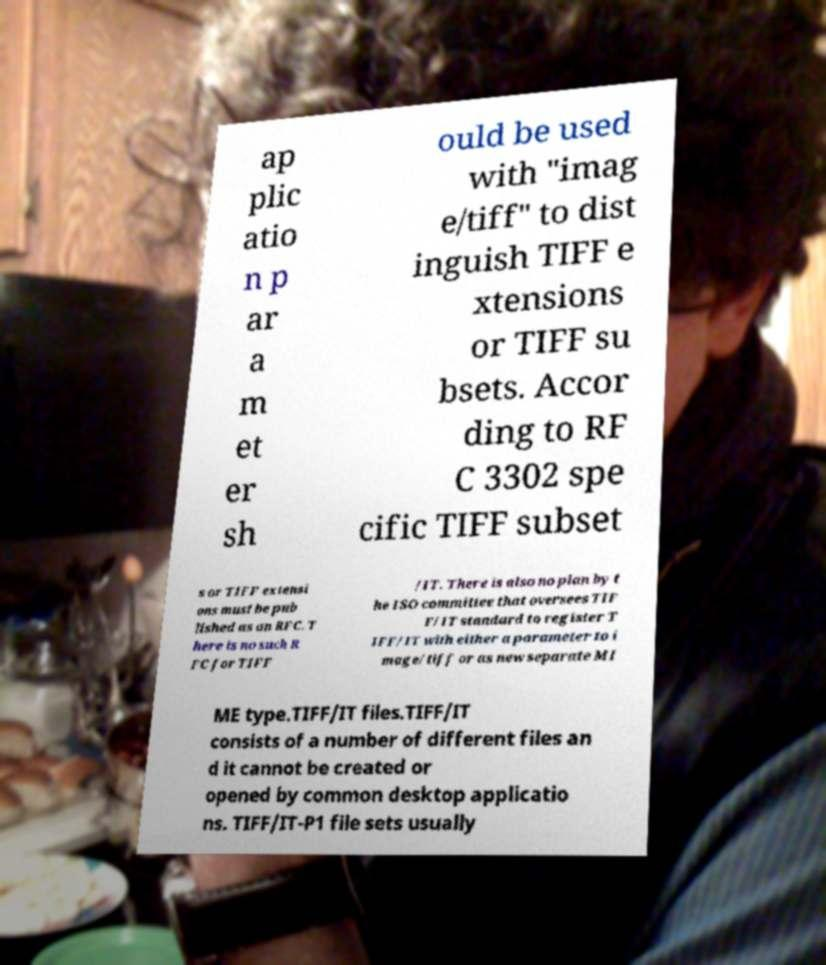Can you read and provide the text displayed in the image?This photo seems to have some interesting text. Can you extract and type it out for me? ap plic atio n p ar a m et er sh ould be used with "imag e/tiff" to dist inguish TIFF e xtensions or TIFF su bsets. Accor ding to RF C 3302 spe cific TIFF subset s or TIFF extensi ons must be pub lished as an RFC. T here is no such R FC for TIFF /IT. There is also no plan by t he ISO committee that oversees TIF F/IT standard to register T IFF/IT with either a parameter to i mage/tiff or as new separate MI ME type.TIFF/IT files.TIFF/IT consists of a number of different files an d it cannot be created or opened by common desktop applicatio ns. TIFF/IT-P1 file sets usually 